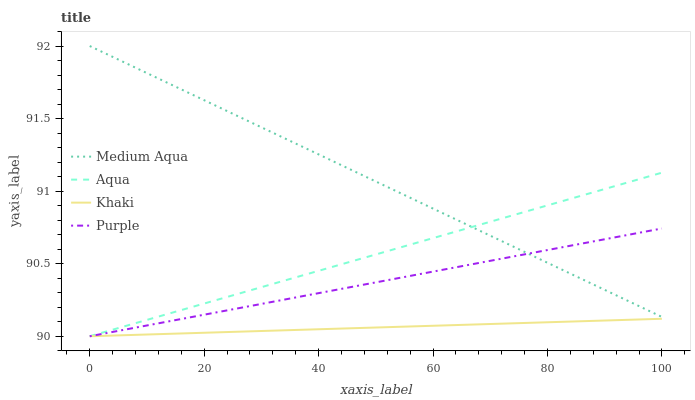Does Khaki have the minimum area under the curve?
Answer yes or no. Yes. Does Medium Aqua have the maximum area under the curve?
Answer yes or no. Yes. Does Aqua have the minimum area under the curve?
Answer yes or no. No. Does Aqua have the maximum area under the curve?
Answer yes or no. No. Is Khaki the smoothest?
Answer yes or no. Yes. Is Medium Aqua the roughest?
Answer yes or no. Yes. Is Aqua the smoothest?
Answer yes or no. No. Is Aqua the roughest?
Answer yes or no. No. Does Purple have the lowest value?
Answer yes or no. Yes. Does Medium Aqua have the lowest value?
Answer yes or no. No. Does Medium Aqua have the highest value?
Answer yes or no. Yes. Does Aqua have the highest value?
Answer yes or no. No. Is Khaki less than Medium Aqua?
Answer yes or no. Yes. Is Medium Aqua greater than Khaki?
Answer yes or no. Yes. Does Medium Aqua intersect Aqua?
Answer yes or no. Yes. Is Medium Aqua less than Aqua?
Answer yes or no. No. Is Medium Aqua greater than Aqua?
Answer yes or no. No. Does Khaki intersect Medium Aqua?
Answer yes or no. No. 